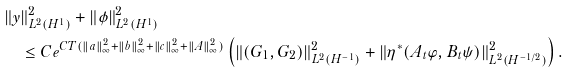<formula> <loc_0><loc_0><loc_500><loc_500>& \| y \| ^ { 2 } _ { L ^ { 2 } ( H ^ { 1 } ) } + \| \phi \| ^ { 2 } _ { L ^ { 2 } ( H ^ { 1 } ) } \\ & \quad \leq C e ^ { C T ( \| a \| ^ { 2 } _ { \infty } + \| b \| ^ { 2 } _ { \infty } + \| c \| ^ { 2 } _ { \infty } + \| A \| ^ { 2 } _ { \infty } ) } \left ( \| ( G _ { 1 } , G _ { 2 } ) \| ^ { 2 } _ { L ^ { 2 } ( H ^ { - 1 } ) } + \| \eta ^ { * } ( A _ { t } \varphi , B _ { t } \psi ) \| ^ { 2 } _ { L ^ { 2 } ( H ^ { - 1 / 2 } ) } \right ) .</formula> 